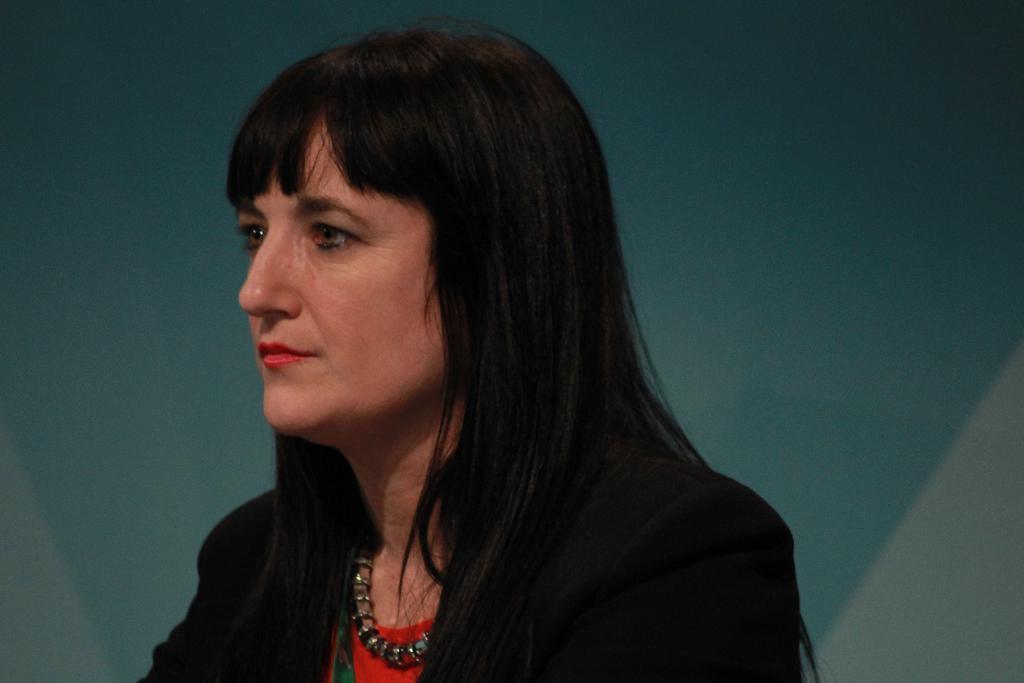Can you describe this image briefly? In this picture I can see a woman in front who is wearing black and red color dress and I see a necklace around her neck and I see the white and blue color background. 